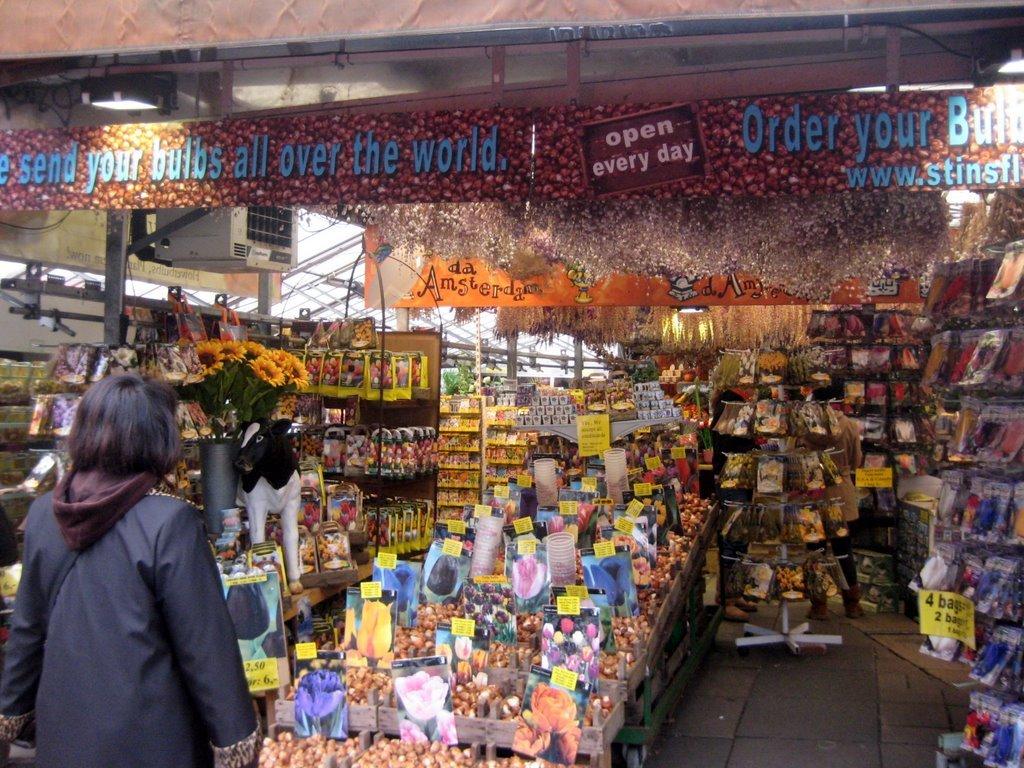Where can the bulbs be sent?
Offer a very short reply. All over the world. Send your bulbs all over the world open every day order your?
Your answer should be compact. Bulbs. 